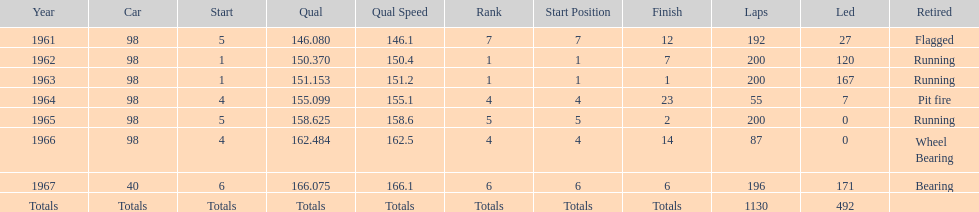Would you mind parsing the complete table? {'header': ['Year', 'Car', 'Start', 'Qual', 'Qual Speed', 'Rank', 'Start Position', 'Finish', 'Laps', 'Led', 'Retired'], 'rows': [['1961', '98', '5', '146.080', '146.1', '7', '7', '12', '192', '27', 'Flagged'], ['1962', '98', '1', '150.370', '150.4', '1', '1', '7', '200', '120', 'Running'], ['1963', '98', '1', '151.153', '151.2', '1', '1', '1', '200', '167', 'Running'], ['1964', '98', '4', '155.099', '155.1', '4', '4', '23', '55', '7', 'Pit fire'], ['1965', '98', '5', '158.625', '158.6', '5', '5', '2', '200', '0', 'Running'], ['1966', '98', '4', '162.484', '162.5', '4', '4', '14', '87', '0', 'Wheel Bearing'], ['1967', '40', '6', '166.075', '166.1', '6', '6', '6', '196', '171', 'Bearing'], ['Totals', 'Totals', 'Totals', 'Totals', 'Totals', 'Totals', 'Totals', 'Totals', '1130', '492', '']]} What is the most common cause for a retired car? Running. 